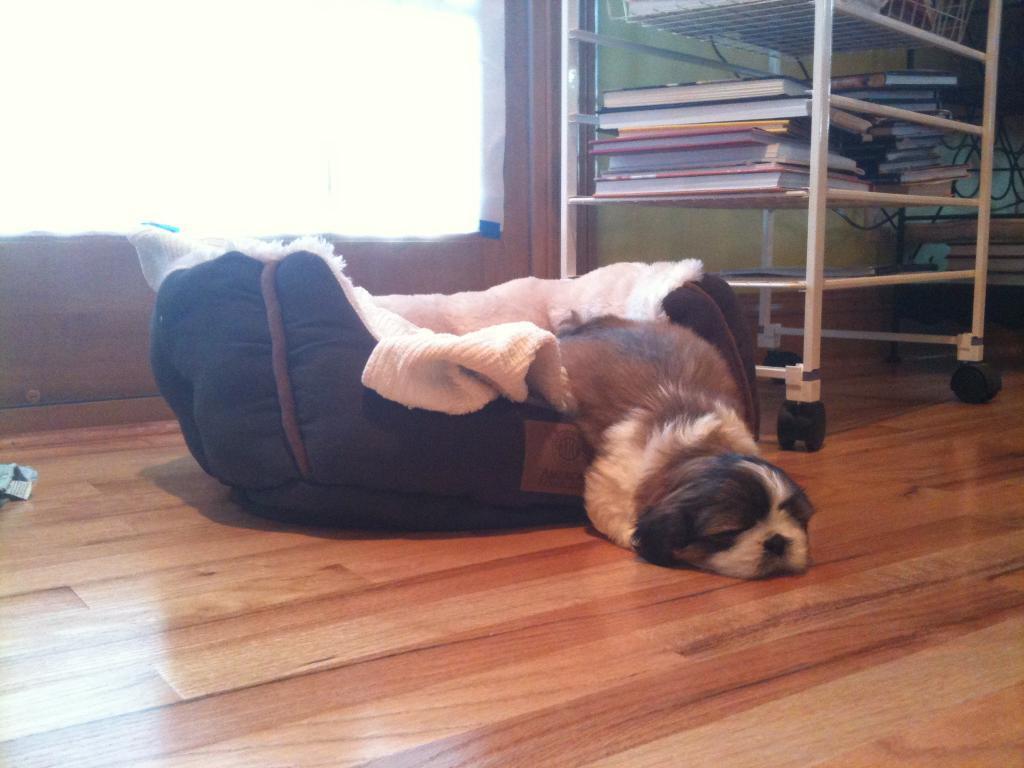Could you give a brief overview of what you see in this image? In this picture I can observe a dog laying on its bed and floor. The floor is in brown color. On the right side I can observe a rack in which some books are placed. In the background there is a window. 